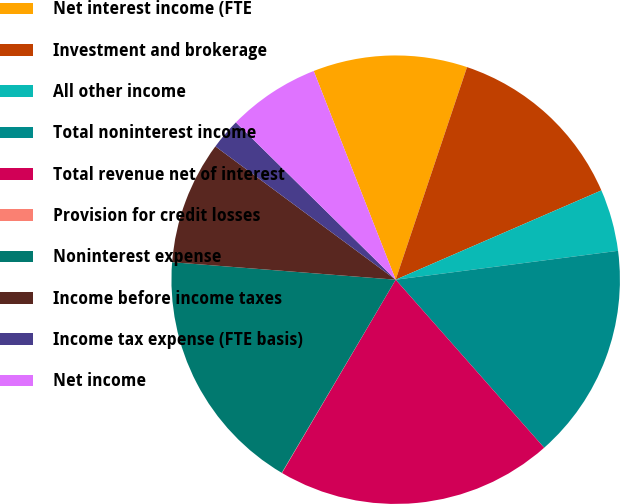<chart> <loc_0><loc_0><loc_500><loc_500><pie_chart><fcel>Net interest income (FTE<fcel>Investment and brokerage<fcel>All other income<fcel>Total noninterest income<fcel>Total revenue net of interest<fcel>Provision for credit losses<fcel>Noninterest expense<fcel>Income before income taxes<fcel>Income tax expense (FTE basis)<fcel>Net income<nl><fcel>11.11%<fcel>13.33%<fcel>4.46%<fcel>15.54%<fcel>19.98%<fcel>0.02%<fcel>17.76%<fcel>8.89%<fcel>2.24%<fcel>6.67%<nl></chart> 